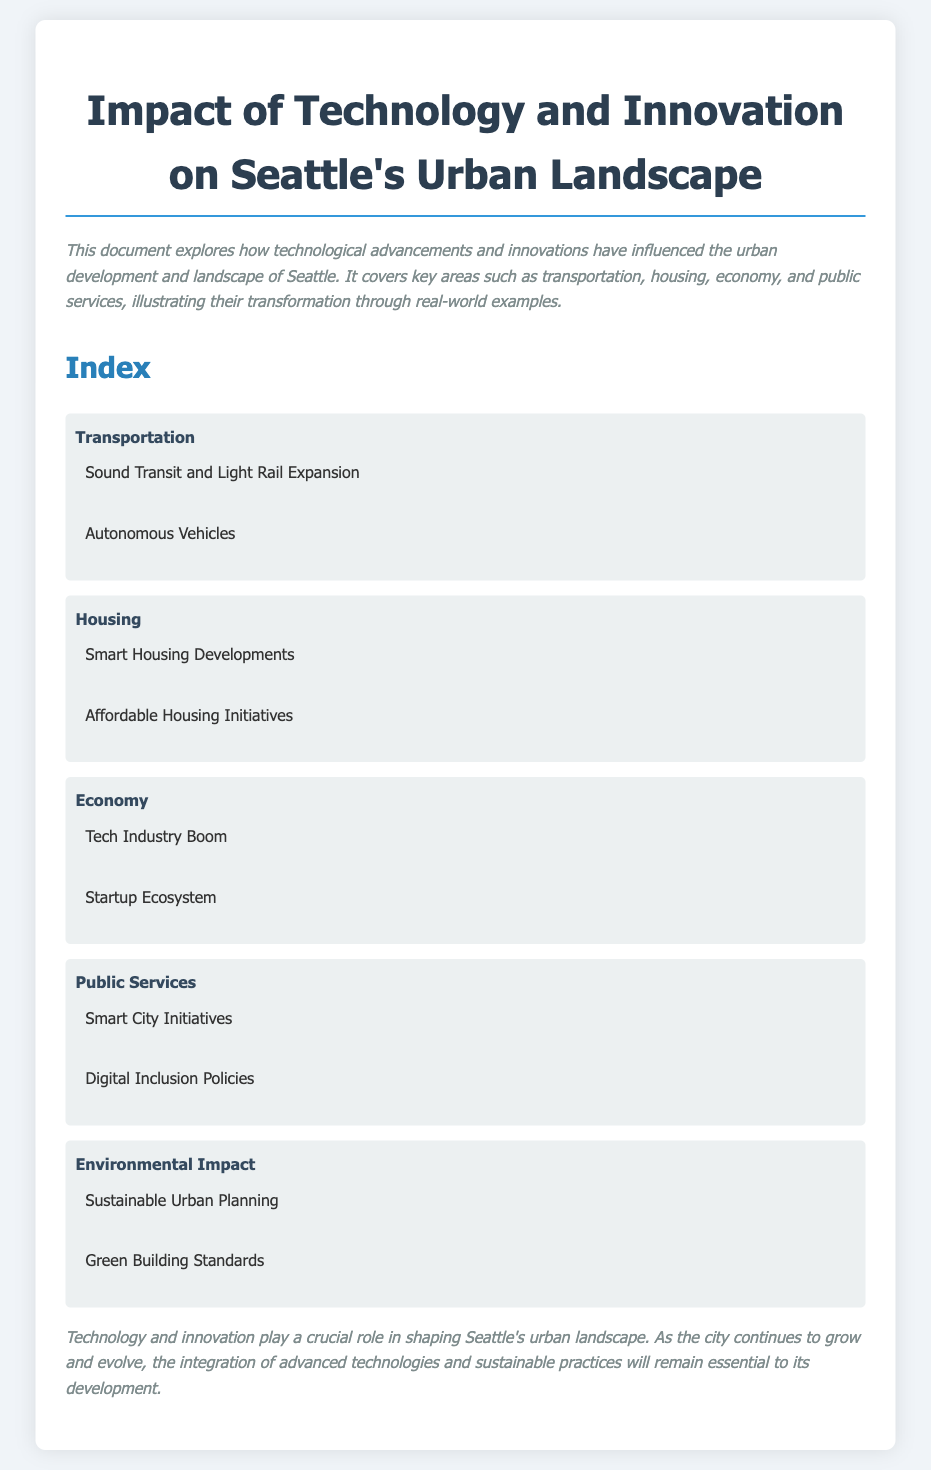what are the two main categories discussed in the document? The document outlines several key areas of impact, namely Transportation and Housing, among others.
Answer: Transportation and Housing which public service initiative is mentioned in the document? The document lists Smart City Initiatives as part of the public services impacted by technology.
Answer: Smart City Initiatives what does the section on housing include? The housing section covers Smart Housing Developments and Affordable Housing Initiatives.
Answer: Smart Housing Developments, Affordable Housing Initiatives how has the economy been influenced according to the document? The document specifies that the Tech Industry Boom and Startup Ecosystem are significant aspects of how technology has shaped Seattle's economy.
Answer: Tech Industry Boom, Startup Ecosystem name one environmental aspect addressed in the document. The document discusses Sustainable Urban Planning as an environmental aspect influenced by technology.
Answer: Sustainable Urban Planning how does the document categorize the influence of technology? It categorizes the influence of technology into Transportation, Housing, Economy, Public Services, and Environmental Impact.
Answer: Transportation, Housing, Economy, Public Services, Environmental Impact what type of document is this? The document is an Index that summarizes the impacts of technology on urban development in Seattle.
Answer: Index which transportation project is highlighted? Sound Transit and Light Rail Expansion are highlighted as part of the transportation initiatives.
Answer: Sound Transit and Light Rail Expansion 